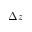<formula> <loc_0><loc_0><loc_500><loc_500>\Delta z</formula> 